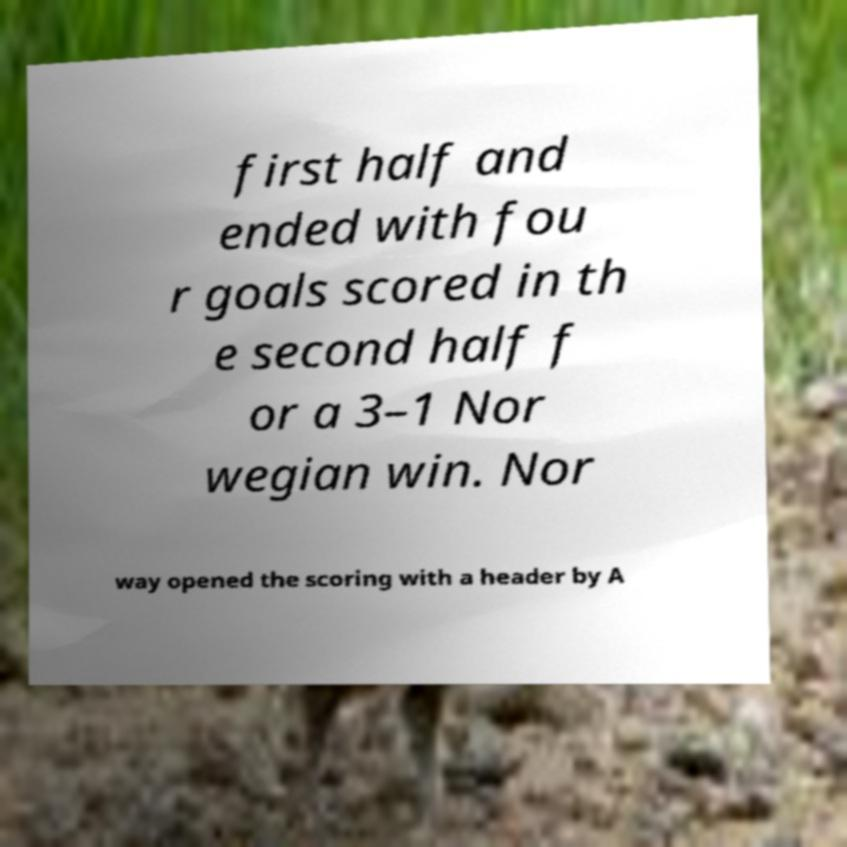Could you extract and type out the text from this image? first half and ended with fou r goals scored in th e second half f or a 3–1 Nor wegian win. Nor way opened the scoring with a header by A 